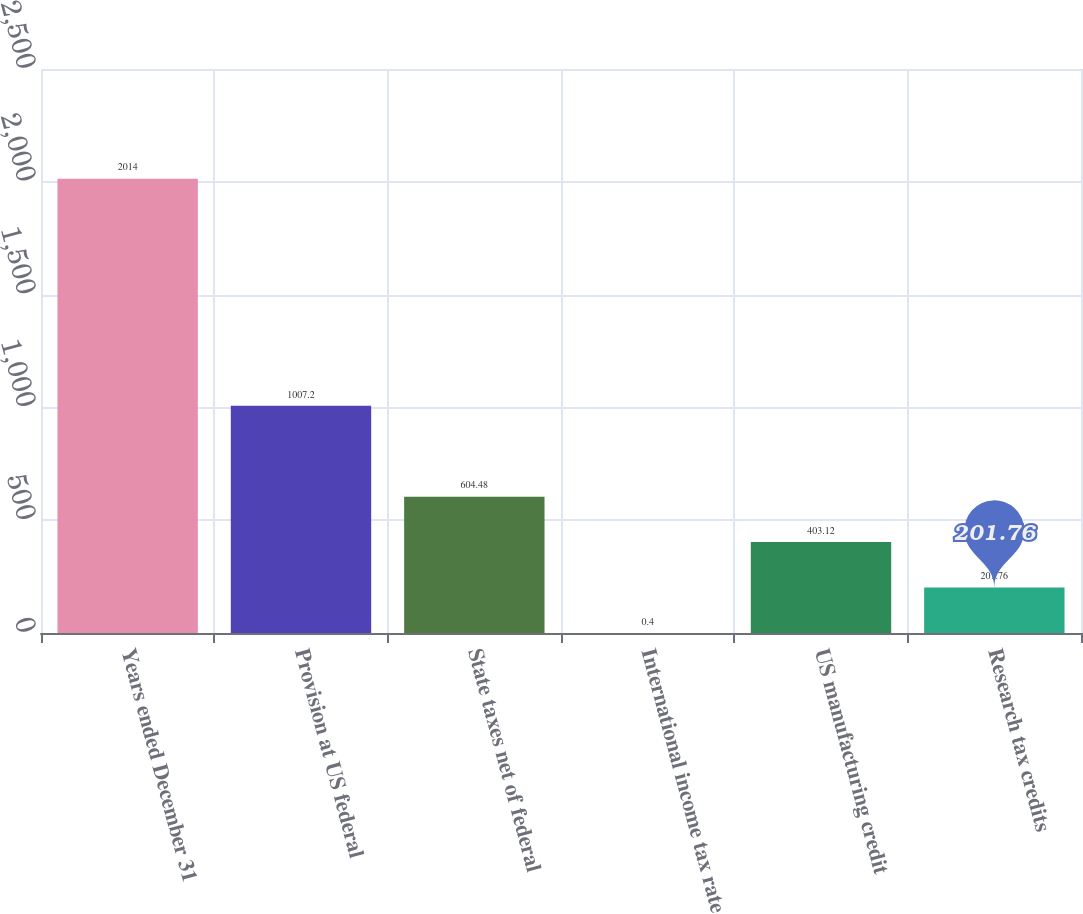Convert chart. <chart><loc_0><loc_0><loc_500><loc_500><bar_chart><fcel>Years ended December 31<fcel>Provision at US federal<fcel>State taxes net of federal<fcel>International income tax rate<fcel>US manufacturing credit<fcel>Research tax credits<nl><fcel>2014<fcel>1007.2<fcel>604.48<fcel>0.4<fcel>403.12<fcel>201.76<nl></chart> 